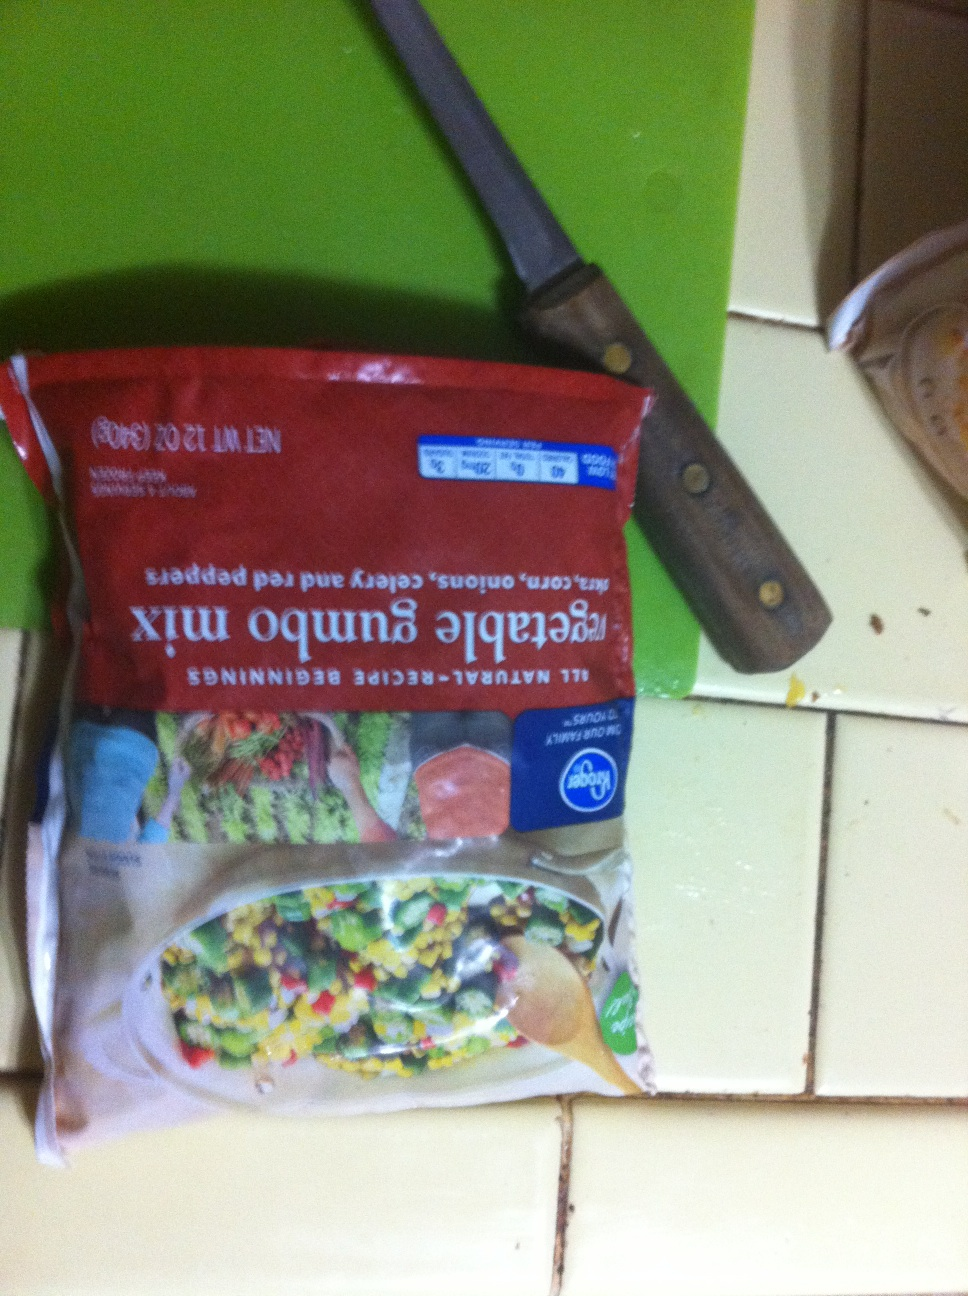In a post-apocalyptic scenario, how could this vegetable mix be a lifesaver? In a post-apocalyptic scenario, this vegetable gumbo mix could be a lifesaver by providing essential nutrients when fresh produce is scarce. The mix’s combination of sweet corn, onions, celery, and red bell peppers offers a variety of vitamins and minerals that could help maintain health and energy. Since it's frozen, it has a longer shelf life and can be stored for future use. Additionally, the mix can be used to cook hearty and nutritious meals that could keep survivors strong and resilient in tough conditions.  How should I cook this vegetable mix if I have very few resources in a survival situation? In a survival situation with limited resources, you can cook this vegetable mix using a straightforward method. Start by heating a small amount of any available oil or fat in a single pot over a fire or any heat source. Add the vegetable mix and sauté until they become tender. If you have any available spices or salt, sprinkle them over the vegetables to enhance the flavor. You can also add any available protein such as canned beans, meat, or fish. Cover with water or broth, if you have it, and let it simmer until everything is cooked through. This simple and resourceful method will provide a warm and nutritious meal. 